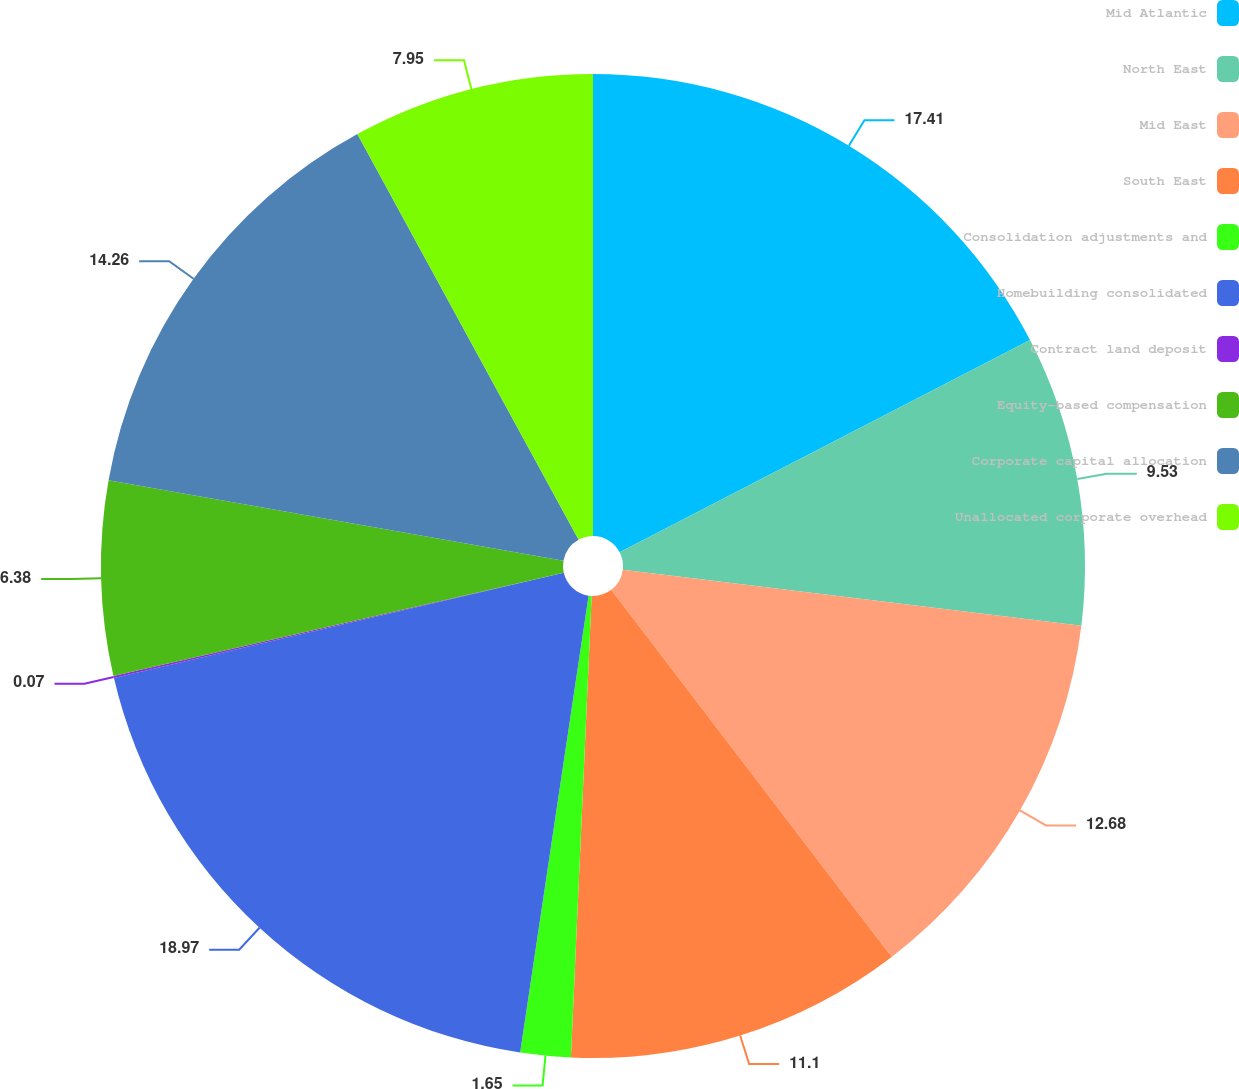Convert chart to OTSL. <chart><loc_0><loc_0><loc_500><loc_500><pie_chart><fcel>Mid Atlantic<fcel>North East<fcel>Mid East<fcel>South East<fcel>Consolidation adjustments and<fcel>Homebuilding consolidated<fcel>Contract land deposit<fcel>Equity-based compensation<fcel>Corporate capital allocation<fcel>Unallocated corporate overhead<nl><fcel>17.41%<fcel>9.53%<fcel>12.68%<fcel>11.1%<fcel>1.65%<fcel>18.98%<fcel>0.07%<fcel>6.38%<fcel>14.26%<fcel>7.95%<nl></chart> 